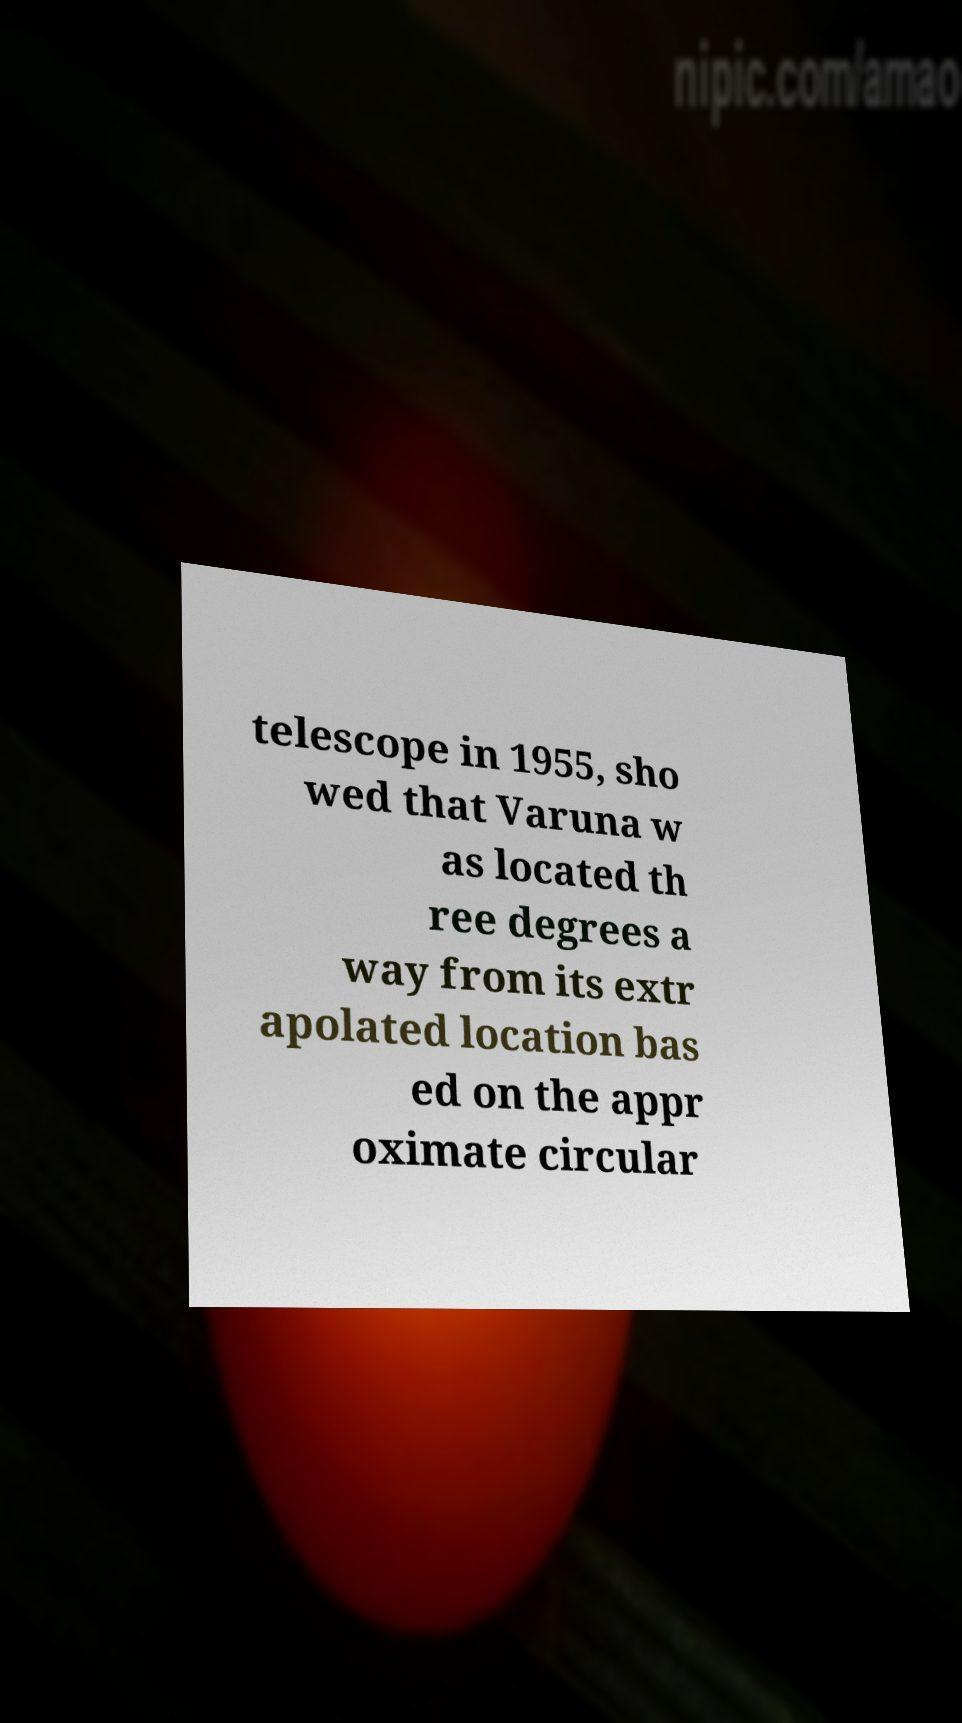Could you assist in decoding the text presented in this image and type it out clearly? telescope in 1955, sho wed that Varuna w as located th ree degrees a way from its extr apolated location bas ed on the appr oximate circular 